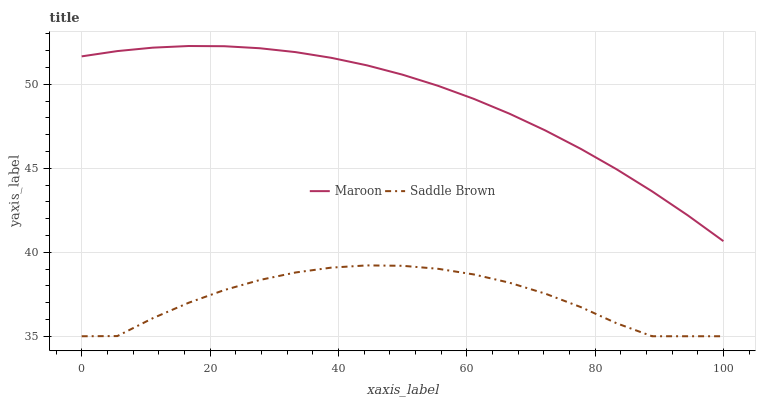Does Saddle Brown have the minimum area under the curve?
Answer yes or no. Yes. Does Maroon have the maximum area under the curve?
Answer yes or no. Yes. Does Maroon have the minimum area under the curve?
Answer yes or no. No. Is Maroon the smoothest?
Answer yes or no. Yes. Is Saddle Brown the roughest?
Answer yes or no. Yes. Is Maroon the roughest?
Answer yes or no. No. Does Saddle Brown have the lowest value?
Answer yes or no. Yes. Does Maroon have the lowest value?
Answer yes or no. No. Does Maroon have the highest value?
Answer yes or no. Yes. Is Saddle Brown less than Maroon?
Answer yes or no. Yes. Is Maroon greater than Saddle Brown?
Answer yes or no. Yes. Does Saddle Brown intersect Maroon?
Answer yes or no. No. 